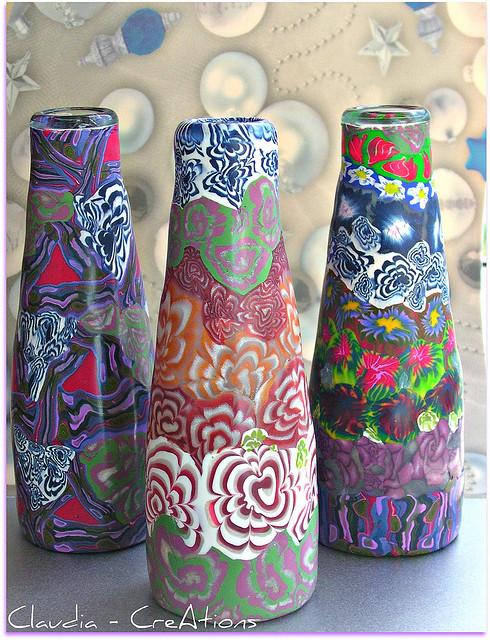What is this a picture of?
Keep it brief. Vases. How many bottles are there?
Give a very brief answer. 3. How many spheres are in the background image?
Answer briefly. 12. 